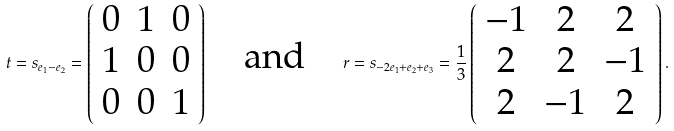<formula> <loc_0><loc_0><loc_500><loc_500>t = s _ { e _ { 1 } - e _ { 2 } } = \left ( \begin{array} { c c c } 0 & 1 & 0 \\ 1 & 0 & 0 \\ 0 & 0 & 1 \end{array} \right ) \quad \text {and} \quad r = s _ { - 2 e _ { 1 } + e _ { 2 } + e _ { 3 } } = \frac { 1 } { 3 } \left ( \begin{array} { c c c } - 1 & 2 & 2 \\ 2 & 2 & - 1 \\ 2 & - 1 & 2 \end{array} \right ) .</formula> 